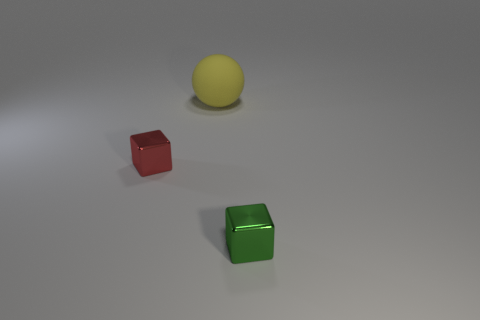What shape is the thing to the left of the large yellow matte thing that is behind the green metallic block?
Give a very brief answer. Cube. Are there any red objects of the same size as the green shiny block?
Your response must be concise. Yes. Are there fewer tiny red blocks than large yellow cylinders?
Make the answer very short. No. There is a thing that is in front of the tiny metallic thing to the left of the tiny object on the right side of the red shiny object; what is its shape?
Offer a terse response. Cube. How many objects are either blocks that are on the left side of the green cube or tiny metallic things behind the tiny green metal block?
Keep it short and to the point. 1. Are there any small things to the left of the large yellow object?
Make the answer very short. Yes. What number of things are either tiny metal objects that are on the right side of the sphere or tiny red blocks?
Your answer should be very brief. 2. How many gray objects are matte spheres or tiny metal things?
Offer a very short reply. 0. Is the number of green things that are in front of the big yellow matte sphere less than the number of red metal cubes?
Keep it short and to the point. No. What is the color of the block that is right of the metallic thing that is left of the tiny cube that is to the right of the large rubber sphere?
Make the answer very short. Green. 